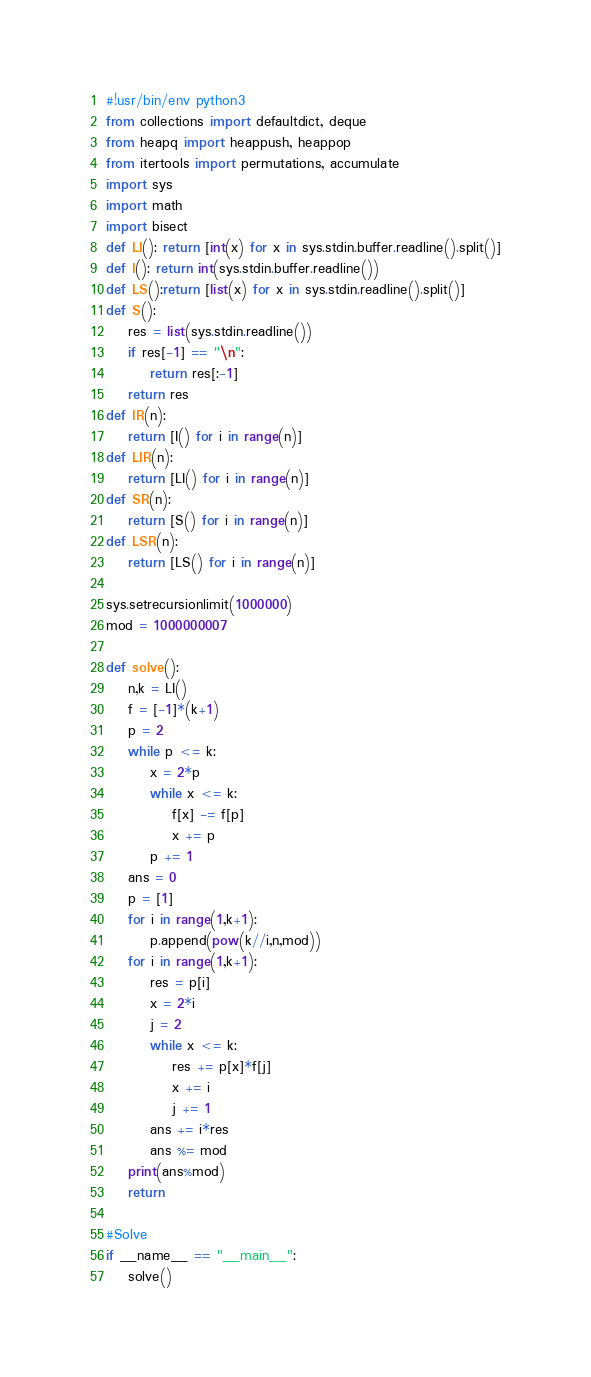<code> <loc_0><loc_0><loc_500><loc_500><_Python_>#!usr/bin/env python3
from collections import defaultdict, deque
from heapq import heappush, heappop
from itertools import permutations, accumulate
import sys
import math
import bisect
def LI(): return [int(x) for x in sys.stdin.buffer.readline().split()]
def I(): return int(sys.stdin.buffer.readline())
def LS():return [list(x) for x in sys.stdin.readline().split()]
def S():
    res = list(sys.stdin.readline())
    if res[-1] == "\n":
        return res[:-1]
    return res
def IR(n):
    return [I() for i in range(n)]
def LIR(n):
    return [LI() for i in range(n)]
def SR(n):
    return [S() for i in range(n)]
def LSR(n):
    return [LS() for i in range(n)]

sys.setrecursionlimit(1000000)
mod = 1000000007

def solve():
    n,k = LI()
    f = [-1]*(k+1)
    p = 2
    while p <= k:
        x = 2*p
        while x <= k:
            f[x] -= f[p]
            x += p
        p += 1
    ans = 0
    p = [1]
    for i in range(1,k+1):
        p.append(pow(k//i,n,mod))
    for i in range(1,k+1):
        res = p[i]
        x = 2*i
        j = 2
        while x <= k:
            res += p[x]*f[j]
            x += i
            j += 1
        ans += i*res
        ans %= mod
    print(ans%mod)
    return

#Solve
if __name__ == "__main__":
    solve()
</code> 